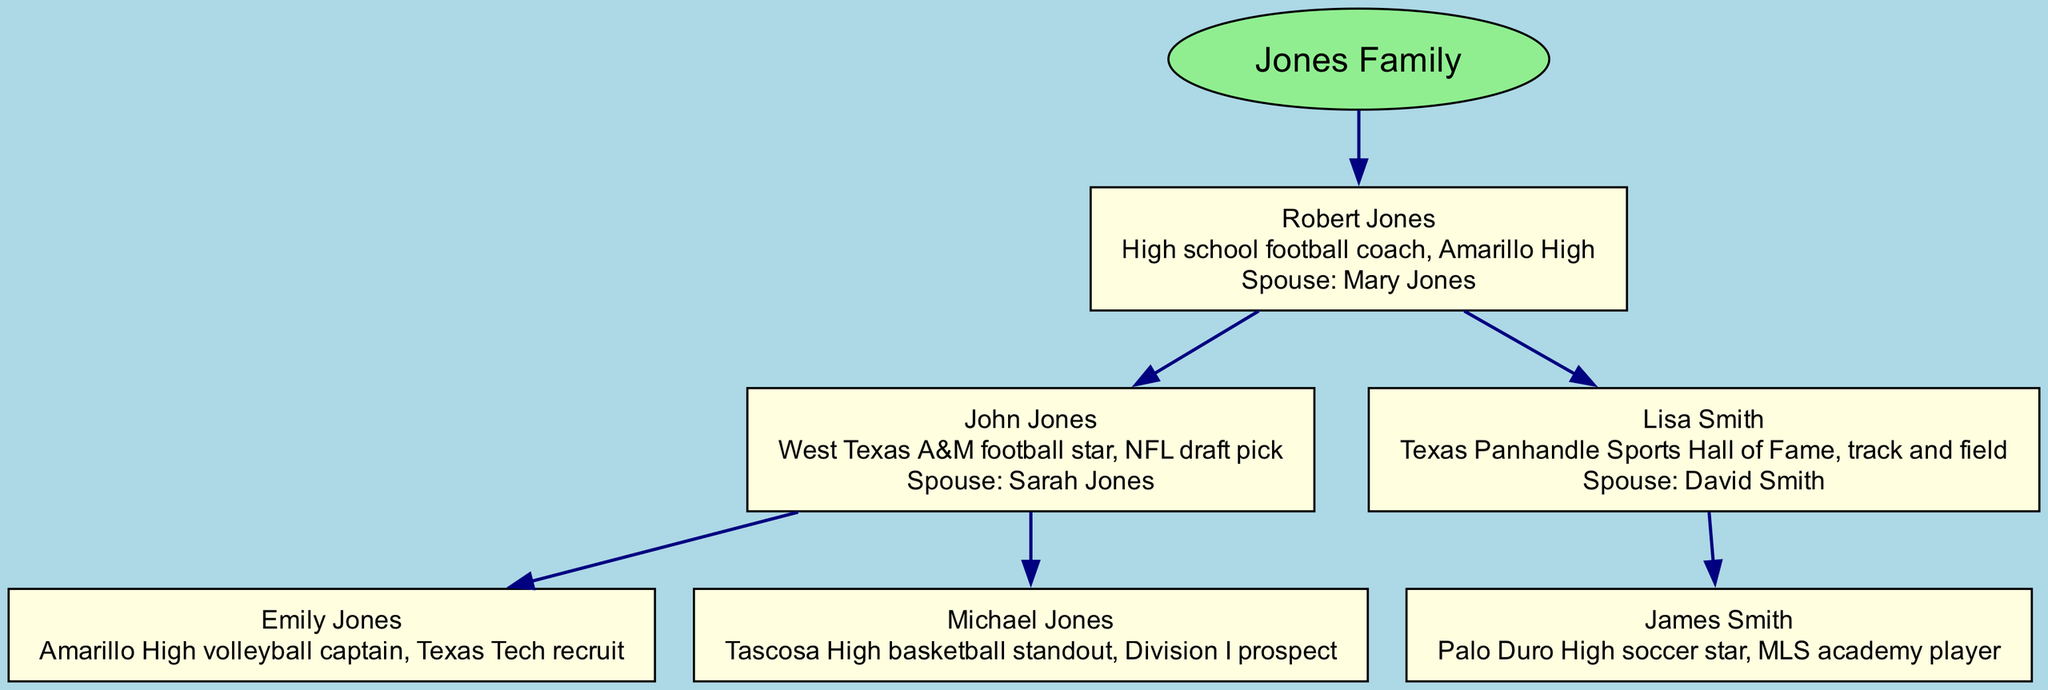What is the name of the patriarch of the Jones family? The diagram clearly indicates that the root of the family tree is "Robert Jones". This is the main individual at the top of the hierarchy, signifying the start of the family lineage.
Answer: Robert Jones Who is the spouse of Lisa Smith? According to the diagram, Lisa Smith is married to David Smith, which is specified in her node. The diagram presents the relationship clearly by displaying both names.
Answer: David Smith How many children does John Jones have? The diagram shows that John Jones has two children, Emily Jones and Michael Jones. This can be counted directly from the child nodes connected to John Jones in the diagram.
Answer: 2 What sport did Emily Jones excel in? From the information provided in the diagram, Emily Jones is noted as the Amarillo High volleyball captain. This is detailed in her node, showing her specific accomplishment.
Answer: Volleyball Which family member is affiliated with the Texas Panhandle Sports Hall of Fame? The diagram states that Lisa Smith holds the honor of being in the Texas Panhandle Sports Hall of Fame, which highlights her athletic achievements in track and field. This can be easily identified from her node.
Answer: Lisa Smith How is Michael Jones related to Robert Jones? Michael Jones is a descendant of Robert Jones, specifically his grandson. This relationship is deduced by tracing the family lineage from the root (Robert Jones) through John Jones to Michael Jones.
Answer: Grandson Who is recognized as a Division I prospect in basketball? The diagram identifies Michael Jones as the Tascosa High basketball standout and a Division I prospect, which is mentioned within his node. This highlights his potential in college sports.
Answer: Michael Jones What relationship does Sarah Jones have with John Jones? Sarah Jones is designated as the spouse of John Jones in the diagram, indicating their marital relationship. This is explicitly stated in John's node.
Answer: Spouse Which child of Robert Jones plays soccer? The diagram indicates that James Smith is noted as a Palo Duro High soccer star. He is the child of Lisa Smith, making him a grandchild of Robert Jones. This can be traced through the branches of the family tree.
Answer: James Smith 